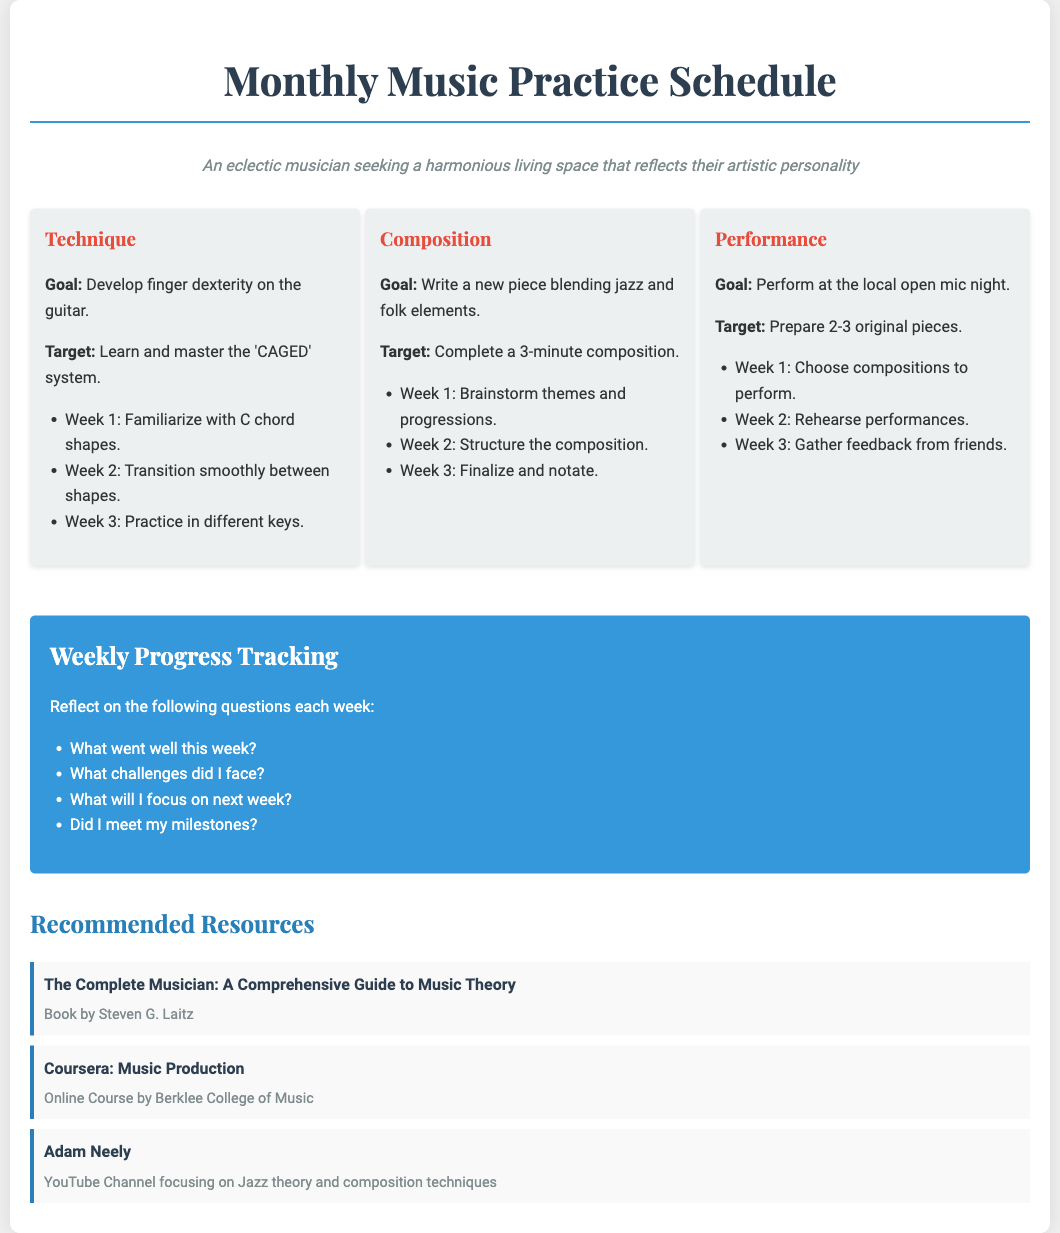What is the main goal for the technique section? The main goal for the technique section is to develop finger dexterity on the guitar.
Answer: Develop finger dexterity on the guitar How many pieces should be prepared for the performance target? The performance target states that 2-3 original pieces should be prepared.
Answer: 2-3 original pieces What is the first task in the composition goal? The first task in the composition goal is to brainstorm themes and progressions.
Answer: Brainstorm themes and progressions What week focuses on gathering feedback from friends? The week focusing on gathering feedback from friends is Week 3 in the performance goal section.
Answer: Week 3 What is the title of the resource listed for comprehensive music theory? The title of the resource listed for comprehensive music theory is "The Complete Musician: A Comprehensive Guide to Music Theory."
Answer: The Complete Musician: A Comprehensive Guide to Music Theory What color is used for the progress tracking section background? The progress tracking section background color is blue.
Answer: Blue What is the target for the composition goal? The target for the composition goal is to complete a 3-minute composition.
Answer: Complete a 3-minute composition What question reflects on challenges faced during the week? The question that reflects on challenges faced during the week is "What challenges did I face?"
Answer: What challenges did I face? What type of musician is the persona in the document? The type of musician described in the persona is an eclectic musician.
Answer: Eclectic musician 